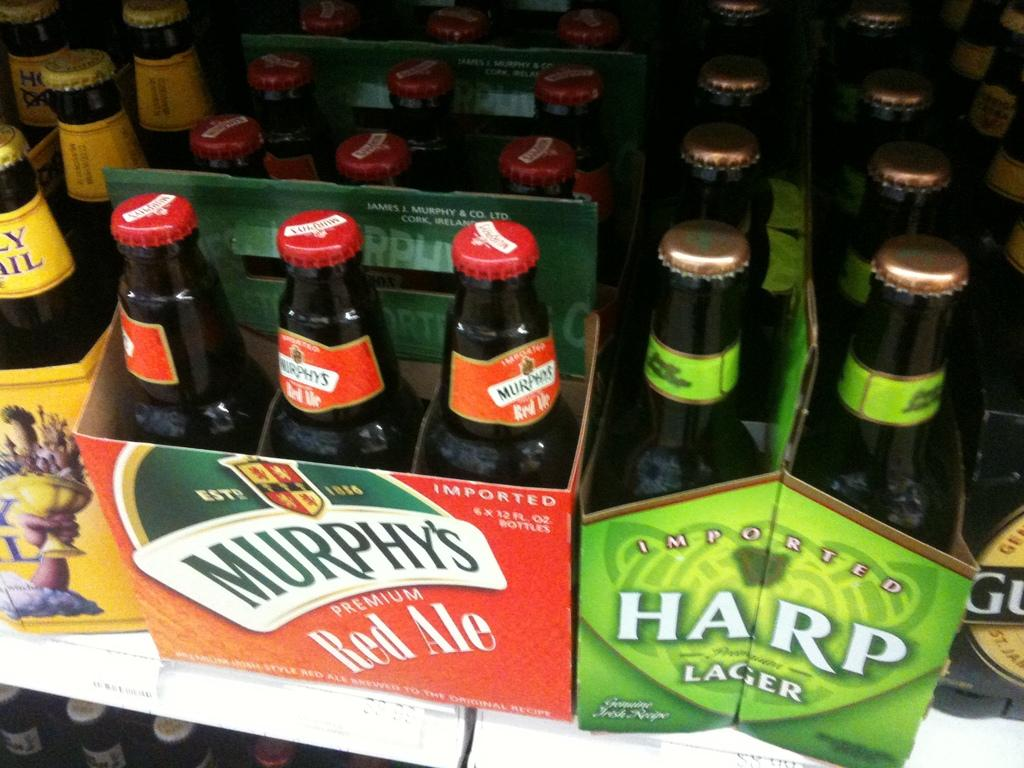Provide a one-sentence caption for the provided image. A six pack of Murphy's red ale and a six pack of Harp lager sitting on a store shelf. 